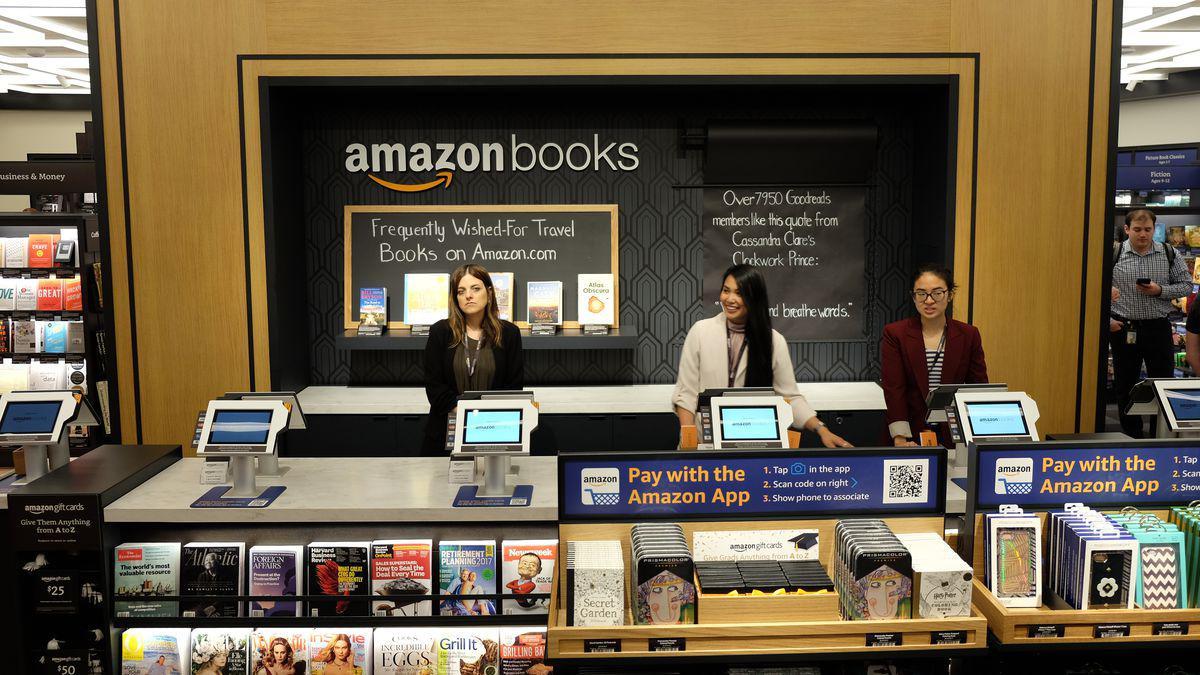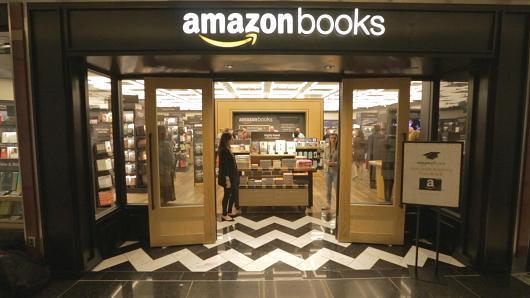The first image is the image on the left, the second image is the image on the right. Analyze the images presented: Is the assertion "One image has an orange poster on the bookshelf that states """"What's the price?"""" and the other image shows a poster that mentions Amazon." valid? Answer yes or no. No. 